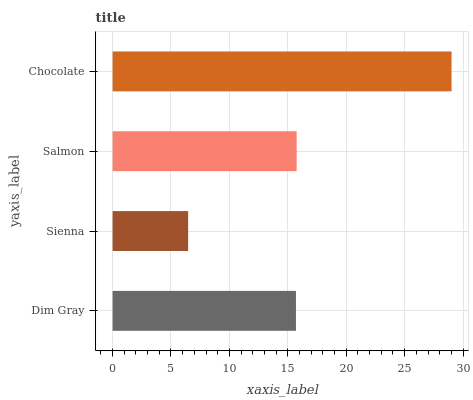Is Sienna the minimum?
Answer yes or no. Yes. Is Chocolate the maximum?
Answer yes or no. Yes. Is Salmon the minimum?
Answer yes or no. No. Is Salmon the maximum?
Answer yes or no. No. Is Salmon greater than Sienna?
Answer yes or no. Yes. Is Sienna less than Salmon?
Answer yes or no. Yes. Is Sienna greater than Salmon?
Answer yes or no. No. Is Salmon less than Sienna?
Answer yes or no. No. Is Salmon the high median?
Answer yes or no. Yes. Is Dim Gray the low median?
Answer yes or no. Yes. Is Chocolate the high median?
Answer yes or no. No. Is Chocolate the low median?
Answer yes or no. No. 